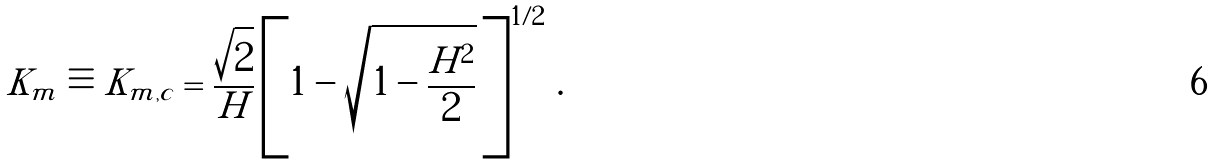<formula> <loc_0><loc_0><loc_500><loc_500>K _ { m } \equiv K _ { m , c } = \frac { \sqrt { 2 } } { H } \left [ 1 - \sqrt { 1 - \frac { H ^ { 2 } } { 2 } } \, \right ] ^ { 1 / 2 } \, .</formula> 